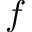Convert formula to latex. <formula><loc_0><loc_0><loc_500><loc_500>f</formula> 